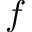Convert formula to latex. <formula><loc_0><loc_0><loc_500><loc_500>f</formula> 